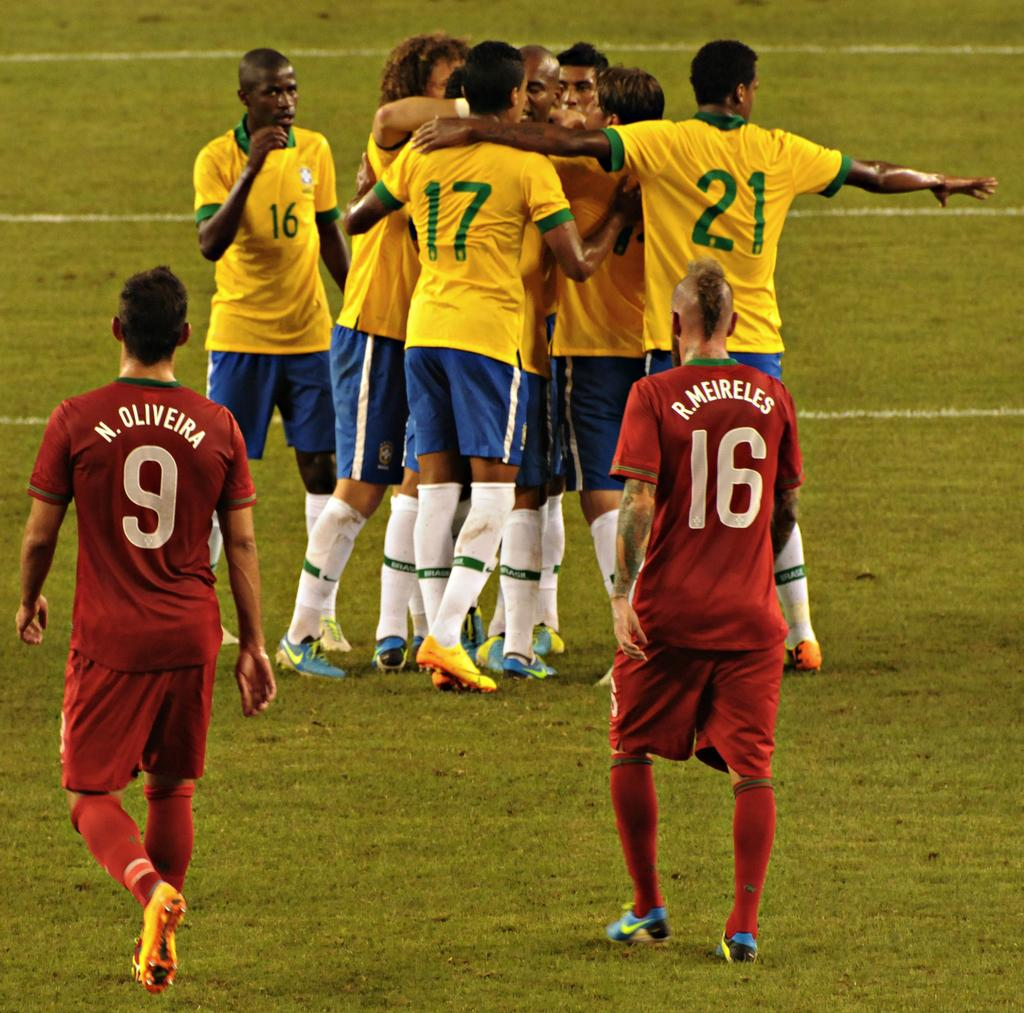Provide a one-sentence caption for the provided image. Two players in red, with N. Oliverira 9 and R. Meireles 16 on their jerseys face a group of players in yellow shirts. 